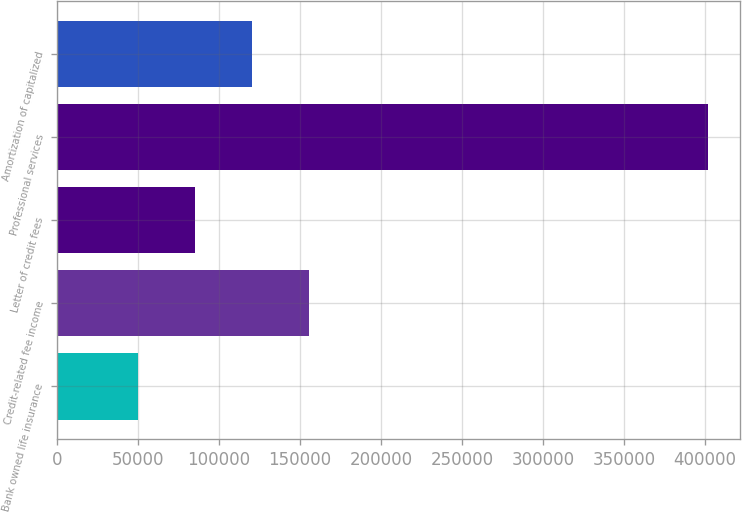Convert chart. <chart><loc_0><loc_0><loc_500><loc_500><bar_chart><fcel>Bank owned life insurance<fcel>Credit-related fee income<fcel>Letter of credit fees<fcel>Professional services<fcel>Amortization of capitalized<nl><fcel>50004<fcel>155587<fcel>85198.2<fcel>401946<fcel>120392<nl></chart> 